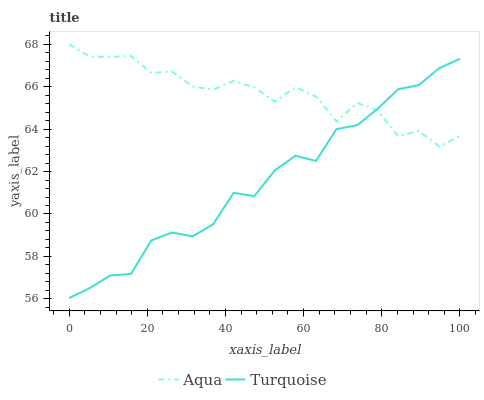Does Turquoise have the minimum area under the curve?
Answer yes or no. Yes. Does Aqua have the maximum area under the curve?
Answer yes or no. Yes. Does Aqua have the minimum area under the curve?
Answer yes or no. No. Is Turquoise the smoothest?
Answer yes or no. Yes. Is Aqua the roughest?
Answer yes or no. Yes. Is Aqua the smoothest?
Answer yes or no. No. Does Turquoise have the lowest value?
Answer yes or no. Yes. Does Aqua have the lowest value?
Answer yes or no. No. Does Aqua have the highest value?
Answer yes or no. Yes. Does Aqua intersect Turquoise?
Answer yes or no. Yes. Is Aqua less than Turquoise?
Answer yes or no. No. Is Aqua greater than Turquoise?
Answer yes or no. No. 